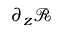<formula> <loc_0><loc_0><loc_500><loc_500>\partial _ { z } \ m a t h s c r { R }</formula> 